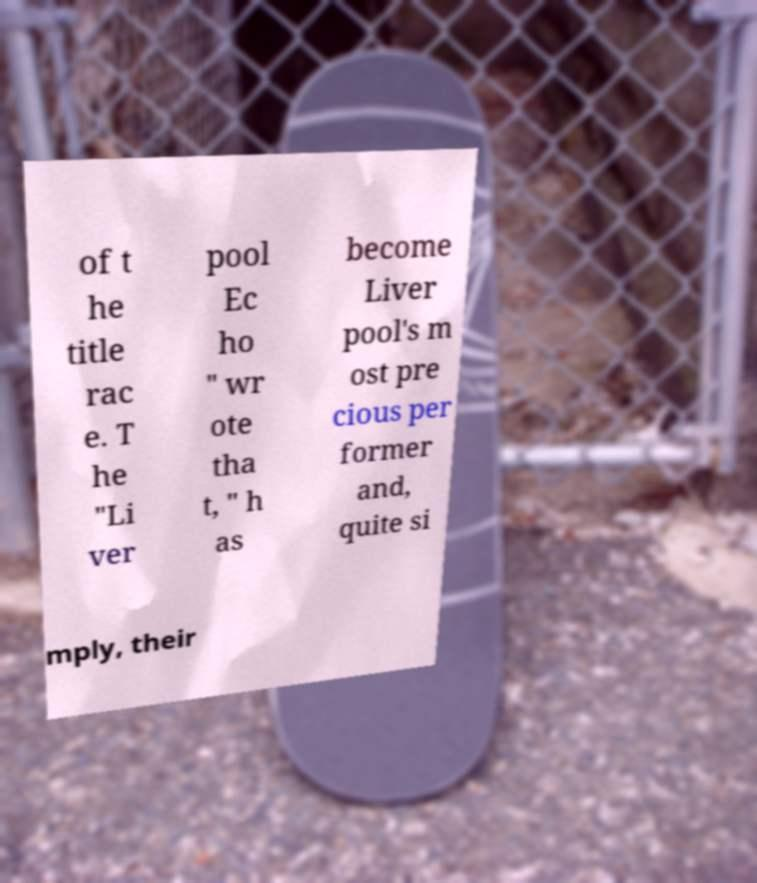Could you assist in decoding the text presented in this image and type it out clearly? of t he title rac e. T he "Li ver pool Ec ho " wr ote tha t, " h as become Liver pool's m ost pre cious per former and, quite si mply, their 